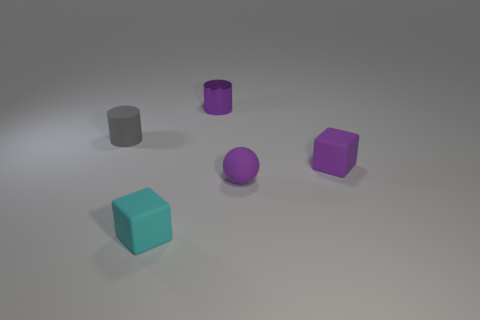Add 1 tiny matte balls. How many objects exist? 6 Subtract all spheres. How many objects are left? 4 Subtract all tiny purple spheres. Subtract all small cylinders. How many objects are left? 2 Add 3 spheres. How many spheres are left? 4 Add 4 big yellow matte cylinders. How many big yellow matte cylinders exist? 4 Subtract 0 gray cubes. How many objects are left? 5 